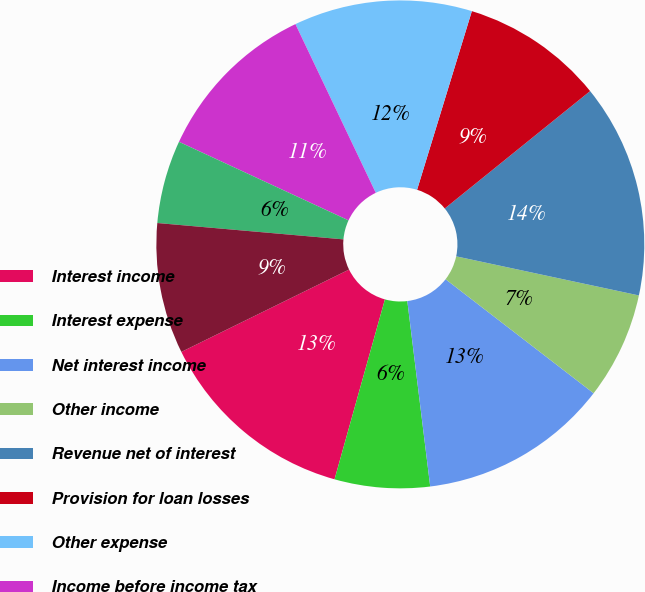<chart> <loc_0><loc_0><loc_500><loc_500><pie_chart><fcel>Interest income<fcel>Interest expense<fcel>Net interest income<fcel>Other income<fcel>Revenue net of interest<fcel>Provision for loan losses<fcel>Other expense<fcel>Income before income tax<fcel>Income tax expense<fcel>Net income<nl><fcel>13.39%<fcel>6.3%<fcel>12.6%<fcel>7.09%<fcel>14.17%<fcel>9.45%<fcel>11.81%<fcel>11.02%<fcel>5.51%<fcel>8.66%<nl></chart> 